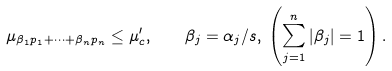Convert formula to latex. <formula><loc_0><loc_0><loc_500><loc_500>\mu _ { \beta _ { 1 } p _ { 1 } + \cdots + \beta _ { n } p _ { n } } \leq \mu ^ { \prime } _ { c } , \quad & \beta _ { j } = \alpha _ { j } / s , \, \left ( \sum _ { j = 1 } ^ { n } | \beta _ { j } | = 1 \right ) .</formula> 